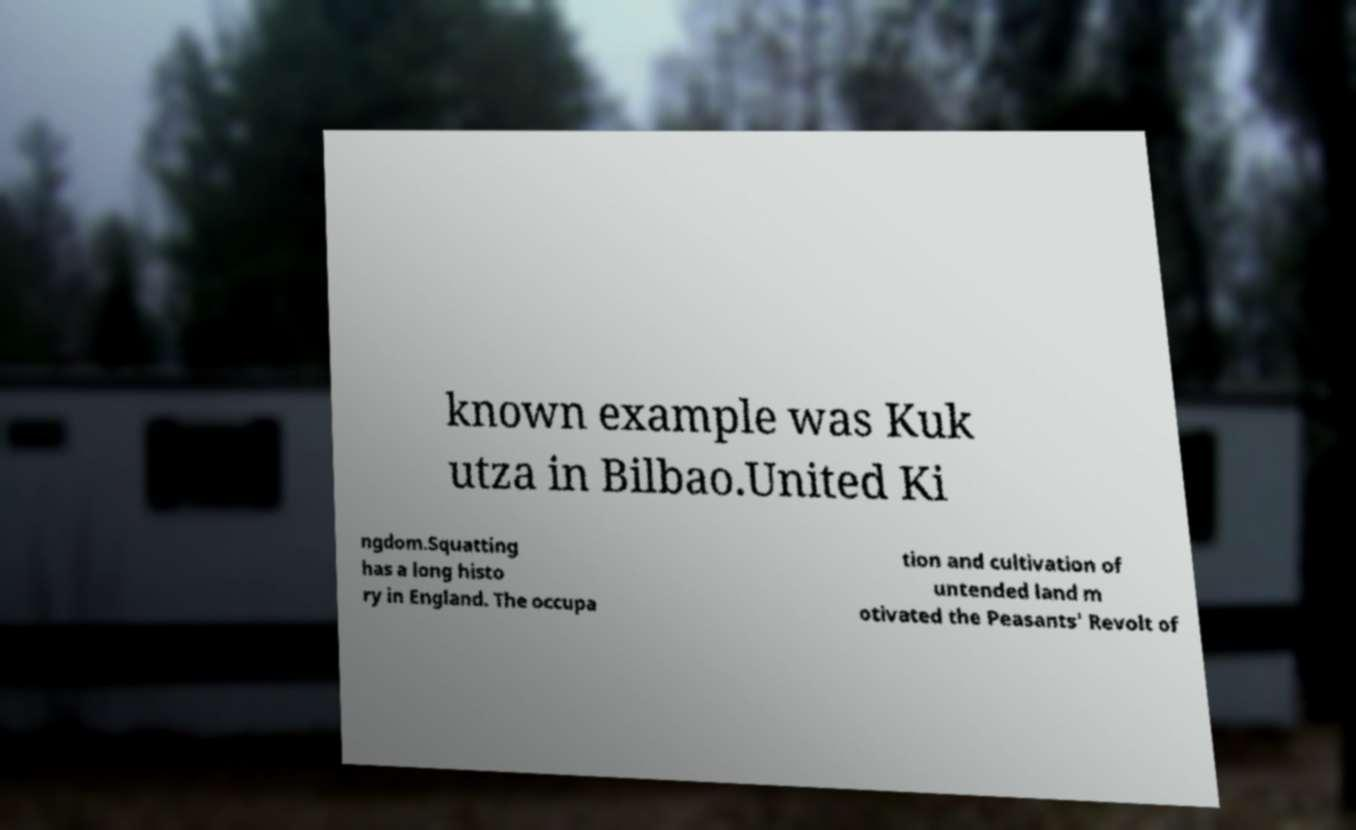Could you assist in decoding the text presented in this image and type it out clearly? known example was Kuk utza in Bilbao.United Ki ngdom.Squatting has a long histo ry in England. The occupa tion and cultivation of untended land m otivated the Peasants' Revolt of 